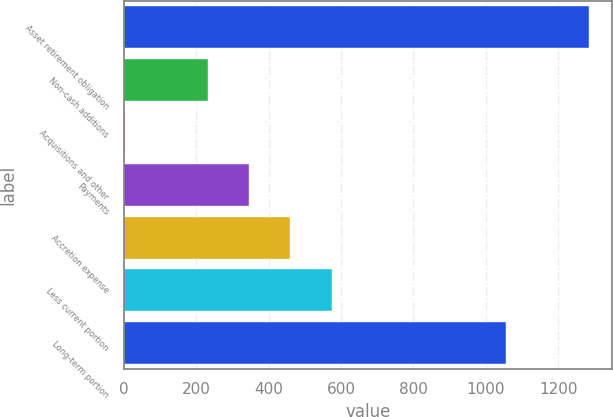Convert chart to OTSL. <chart><loc_0><loc_0><loc_500><loc_500><bar_chart><fcel>Asset retirement obligation<fcel>Non-cash additions<fcel>Acquisitions and other<fcel>Payments<fcel>Accretion expense<fcel>Less current portion<fcel>Long-term portion<nl><fcel>1284.5<fcel>231.9<fcel>3.8<fcel>345.95<fcel>460<fcel>574.05<fcel>1056.4<nl></chart> 